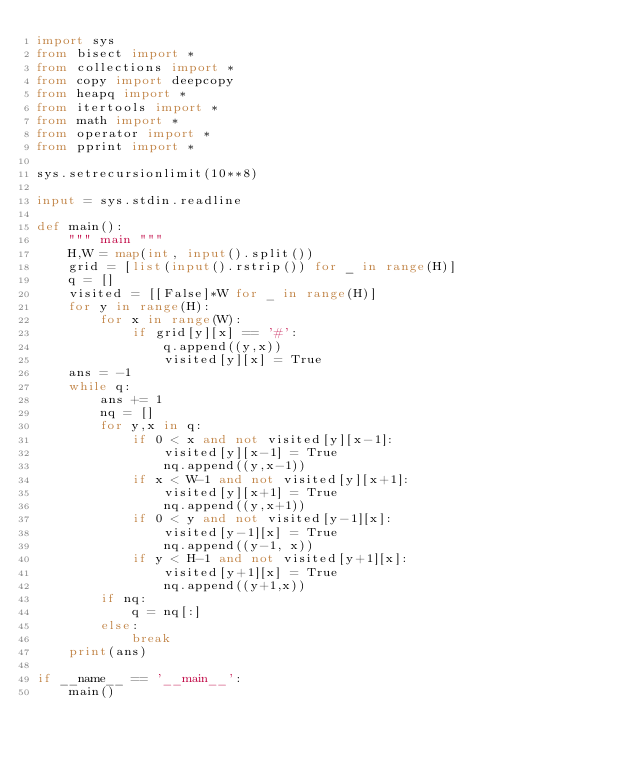Convert code to text. <code><loc_0><loc_0><loc_500><loc_500><_Python_>import sys
from bisect import *
from collections import *
from copy import deepcopy
from heapq import *
from itertools import *
from math import *
from operator import *
from pprint import *

sys.setrecursionlimit(10**8)

input = sys.stdin.readline

def main():
    """ main """
    H,W = map(int, input().split())
    grid = [list(input().rstrip()) for _ in range(H)]
    q = []
    visited = [[False]*W for _ in range(H)]
    for y in range(H):
        for x in range(W):
            if grid[y][x] == '#':
                q.append((y,x))
                visited[y][x] = True
    ans = -1
    while q:
        ans += 1
        nq = []
        for y,x in q:
            if 0 < x and not visited[y][x-1]:
                visited[y][x-1] = True
                nq.append((y,x-1))
            if x < W-1 and not visited[y][x+1]:
                visited[y][x+1] = True
                nq.append((y,x+1))
            if 0 < y and not visited[y-1][x]:
                visited[y-1][x] = True
                nq.append((y-1, x))
            if y < H-1 and not visited[y+1][x]:
                visited[y+1][x] = True
                nq.append((y+1,x))
        if nq:
            q = nq[:]
        else:
            break
    print(ans)

if __name__ == '__main__':
    main()</code> 